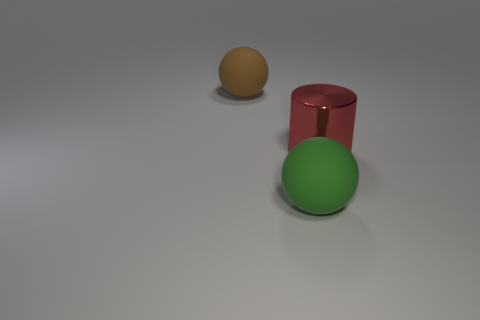Is the material of the large green thing the same as the big red cylinder?
Provide a succinct answer. No. There is a large cylinder that is to the right of the large rubber thing that is in front of the metal object; are there any large red shiny cylinders to the right of it?
Offer a very short reply. No. What is the color of the big shiny thing?
Give a very brief answer. Red. There is a rubber thing that is the same size as the brown rubber sphere; what is its color?
Offer a terse response. Green. There is a rubber thing that is on the left side of the green sphere; is its shape the same as the red thing?
Ensure brevity in your answer.  No. What color is the large rubber ball that is on the right side of the rubber thing left of the rubber thing to the right of the large brown rubber ball?
Your answer should be compact. Green. Are any big red metal cylinders visible?
Keep it short and to the point. Yes. Does the cylinder have the same color as the large rubber ball that is behind the large metal object?
Offer a very short reply. No. What number of things are gray metallic spheres or large metallic things?
Offer a terse response. 1. Is there any other thing that is the same color as the shiny thing?
Ensure brevity in your answer.  No. 